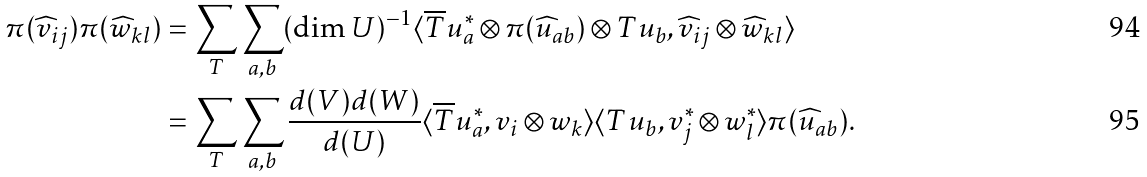Convert formula to latex. <formula><loc_0><loc_0><loc_500><loc_500>\pi ( { \widehat { v } } _ { i j } ) \pi ( { \widehat { w } } _ { k l } ) & = \sum _ { T } \sum _ { a , b } ( \dim U ) ^ { - 1 } \langle { \overline { T } } u _ { a } ^ { * } \otimes \pi ( { \widehat { u } } _ { a b } ) \otimes T u _ { b } , { \widehat { v } } _ { i j } \otimes { \widehat { w } } _ { k l } \rangle \\ & = \sum _ { T } \sum _ { a , b } \frac { d ( V ) d ( W ) } { d ( U ) } \langle { \overline { T } } u _ { a } ^ { * } , v _ { i } \otimes w _ { k } \rangle \langle T u _ { b } , v _ { j } ^ { * } \otimes w _ { l } ^ { * } \rangle \pi ( { \widehat { u } } _ { a b } ) .</formula> 